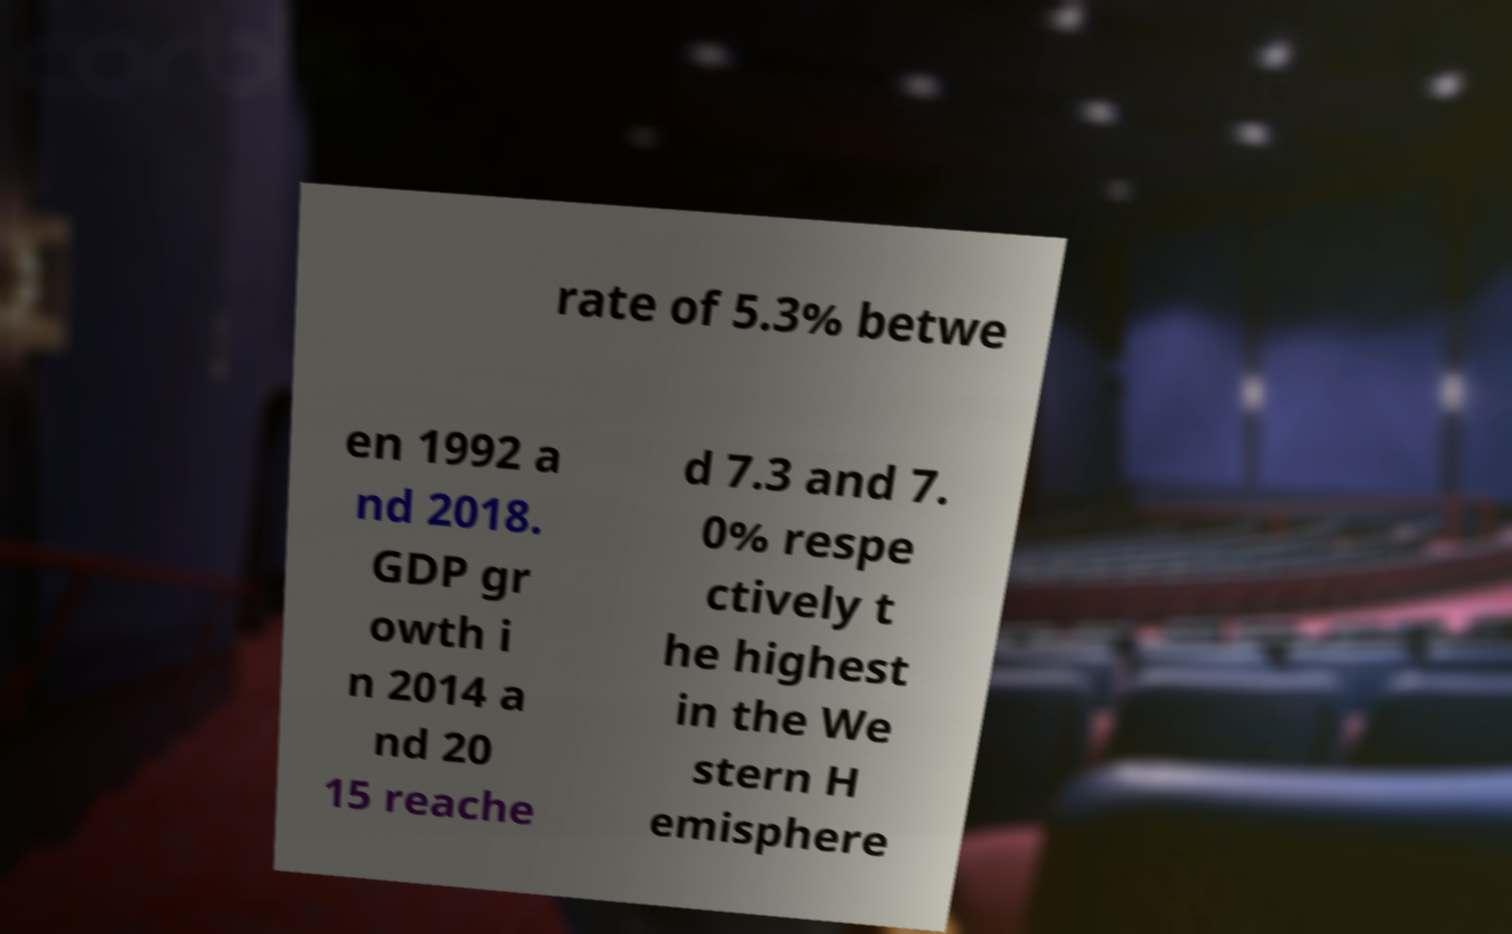There's text embedded in this image that I need extracted. Can you transcribe it verbatim? rate of 5.3% betwe en 1992 a nd 2018. GDP gr owth i n 2014 a nd 20 15 reache d 7.3 and 7. 0% respe ctively t he highest in the We stern H emisphere 